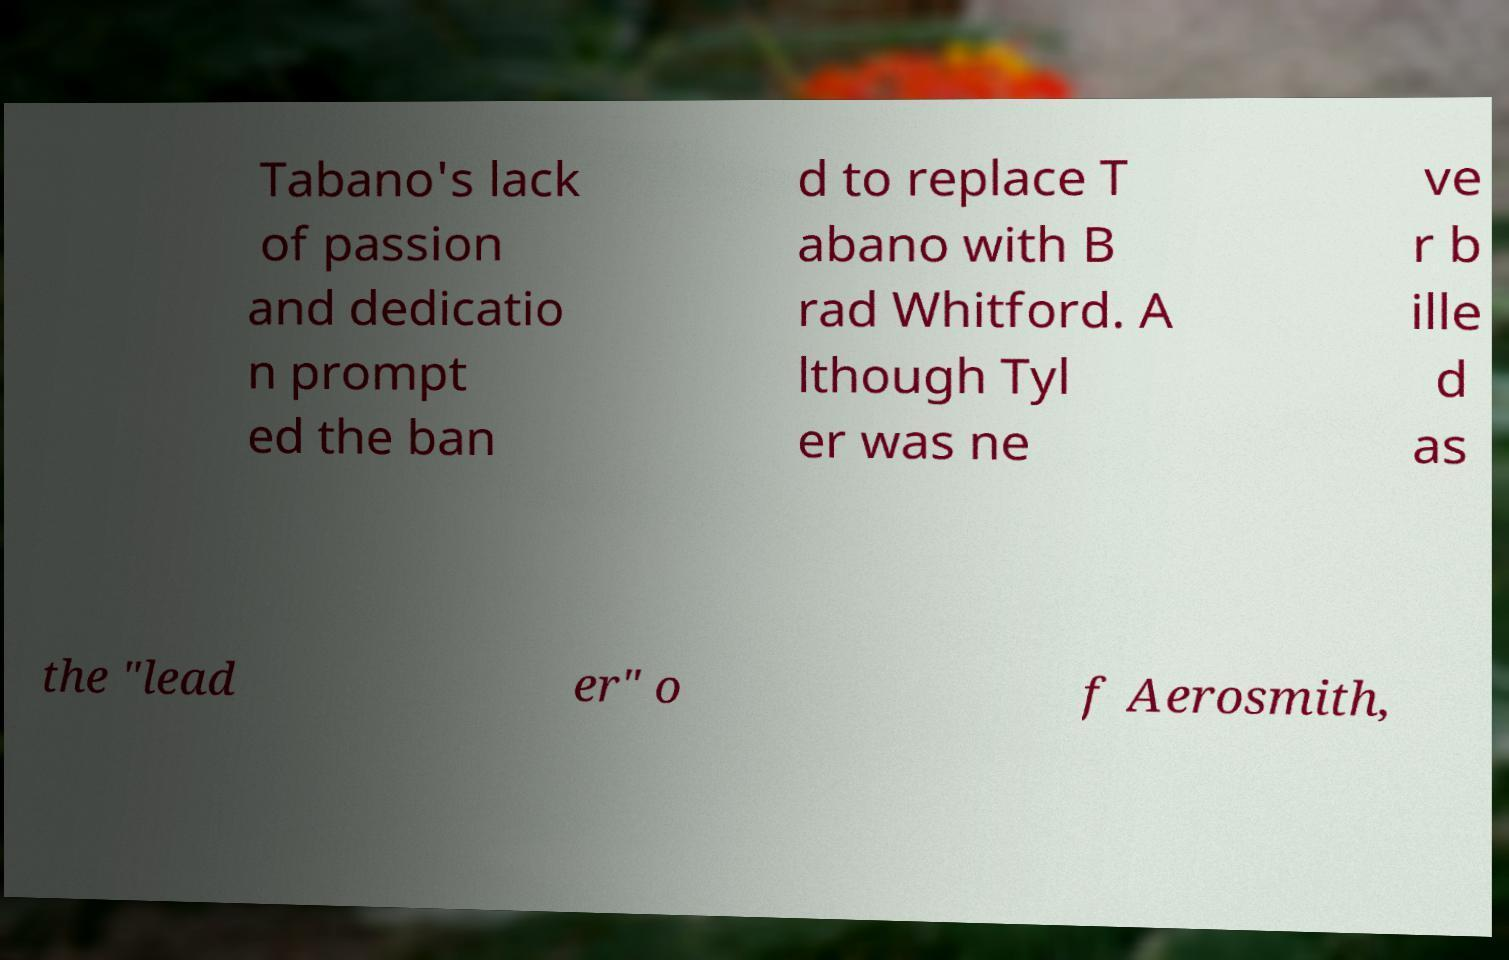What messages or text are displayed in this image? I need them in a readable, typed format. Tabano's lack of passion and dedicatio n prompt ed the ban d to replace T abano with B rad Whitford. A lthough Tyl er was ne ve r b ille d as the "lead er" o f Aerosmith, 